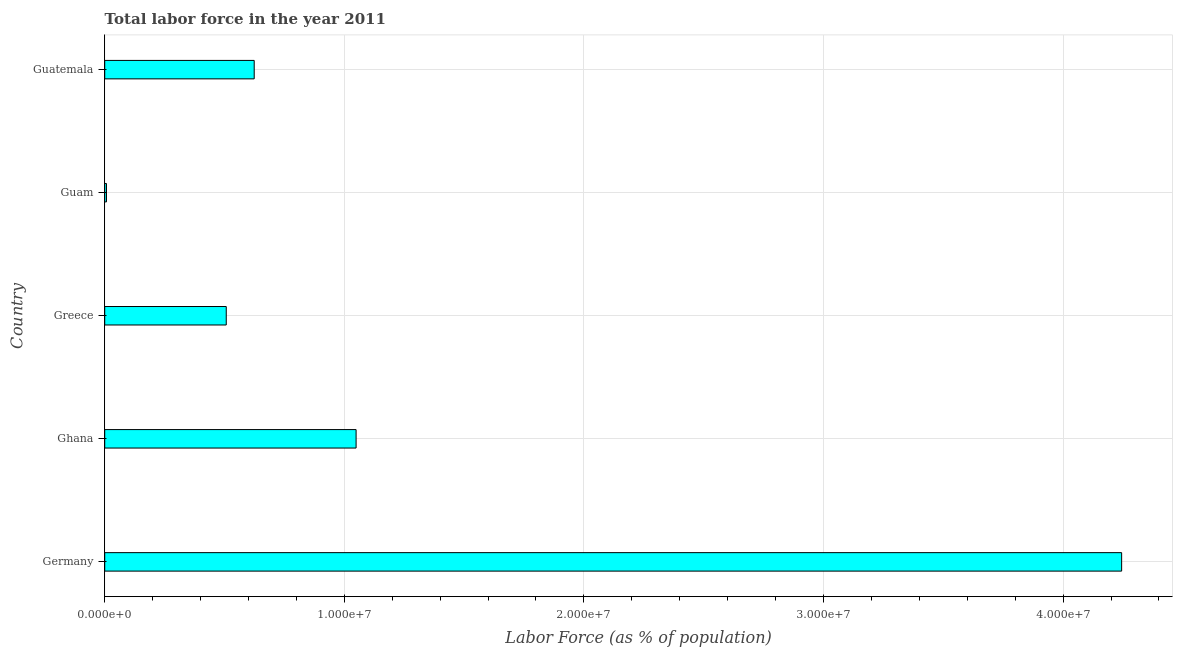What is the title of the graph?
Make the answer very short. Total labor force in the year 2011. What is the label or title of the X-axis?
Your response must be concise. Labor Force (as % of population). What is the label or title of the Y-axis?
Your answer should be compact. Country. What is the total labor force in Germany?
Keep it short and to the point. 4.24e+07. Across all countries, what is the maximum total labor force?
Keep it short and to the point. 4.24e+07. Across all countries, what is the minimum total labor force?
Your response must be concise. 7.37e+04. In which country was the total labor force maximum?
Keep it short and to the point. Germany. In which country was the total labor force minimum?
Keep it short and to the point. Guam. What is the sum of the total labor force?
Provide a short and direct response. 6.43e+07. What is the difference between the total labor force in Germany and Guam?
Offer a terse response. 4.24e+07. What is the average total labor force per country?
Your answer should be compact. 1.29e+07. What is the median total labor force?
Your answer should be compact. 6.24e+06. What is the ratio of the total labor force in Germany to that in Guam?
Make the answer very short. 575.96. Is the total labor force in Ghana less than that in Guam?
Provide a short and direct response. No. What is the difference between the highest and the second highest total labor force?
Offer a very short reply. 3.20e+07. What is the difference between the highest and the lowest total labor force?
Make the answer very short. 4.24e+07. In how many countries, is the total labor force greater than the average total labor force taken over all countries?
Give a very brief answer. 1. How many countries are there in the graph?
Provide a short and direct response. 5. What is the Labor Force (as % of population) in Germany?
Your answer should be very brief. 4.24e+07. What is the Labor Force (as % of population) in Ghana?
Your response must be concise. 1.05e+07. What is the Labor Force (as % of population) in Greece?
Ensure brevity in your answer.  5.07e+06. What is the Labor Force (as % of population) of Guam?
Offer a very short reply. 7.37e+04. What is the Labor Force (as % of population) in Guatemala?
Make the answer very short. 6.24e+06. What is the difference between the Labor Force (as % of population) in Germany and Ghana?
Offer a terse response. 3.20e+07. What is the difference between the Labor Force (as % of population) in Germany and Greece?
Provide a short and direct response. 3.74e+07. What is the difference between the Labor Force (as % of population) in Germany and Guam?
Keep it short and to the point. 4.24e+07. What is the difference between the Labor Force (as % of population) in Germany and Guatemala?
Provide a succinct answer. 3.62e+07. What is the difference between the Labor Force (as % of population) in Ghana and Greece?
Ensure brevity in your answer.  5.42e+06. What is the difference between the Labor Force (as % of population) in Ghana and Guam?
Your answer should be very brief. 1.04e+07. What is the difference between the Labor Force (as % of population) in Ghana and Guatemala?
Make the answer very short. 4.25e+06. What is the difference between the Labor Force (as % of population) in Greece and Guam?
Your answer should be very brief. 5.00e+06. What is the difference between the Labor Force (as % of population) in Greece and Guatemala?
Keep it short and to the point. -1.17e+06. What is the difference between the Labor Force (as % of population) in Guam and Guatemala?
Your answer should be compact. -6.17e+06. What is the ratio of the Labor Force (as % of population) in Germany to that in Ghana?
Ensure brevity in your answer.  4.04. What is the ratio of the Labor Force (as % of population) in Germany to that in Greece?
Offer a terse response. 8.37. What is the ratio of the Labor Force (as % of population) in Germany to that in Guam?
Your answer should be very brief. 575.96. What is the ratio of the Labor Force (as % of population) in Germany to that in Guatemala?
Provide a short and direct response. 6.8. What is the ratio of the Labor Force (as % of population) in Ghana to that in Greece?
Your answer should be compact. 2.07. What is the ratio of the Labor Force (as % of population) in Ghana to that in Guam?
Your response must be concise. 142.38. What is the ratio of the Labor Force (as % of population) in Ghana to that in Guatemala?
Offer a very short reply. 1.68. What is the ratio of the Labor Force (as % of population) in Greece to that in Guam?
Offer a terse response. 68.83. What is the ratio of the Labor Force (as % of population) in Greece to that in Guatemala?
Your answer should be compact. 0.81. What is the ratio of the Labor Force (as % of population) in Guam to that in Guatemala?
Make the answer very short. 0.01. 